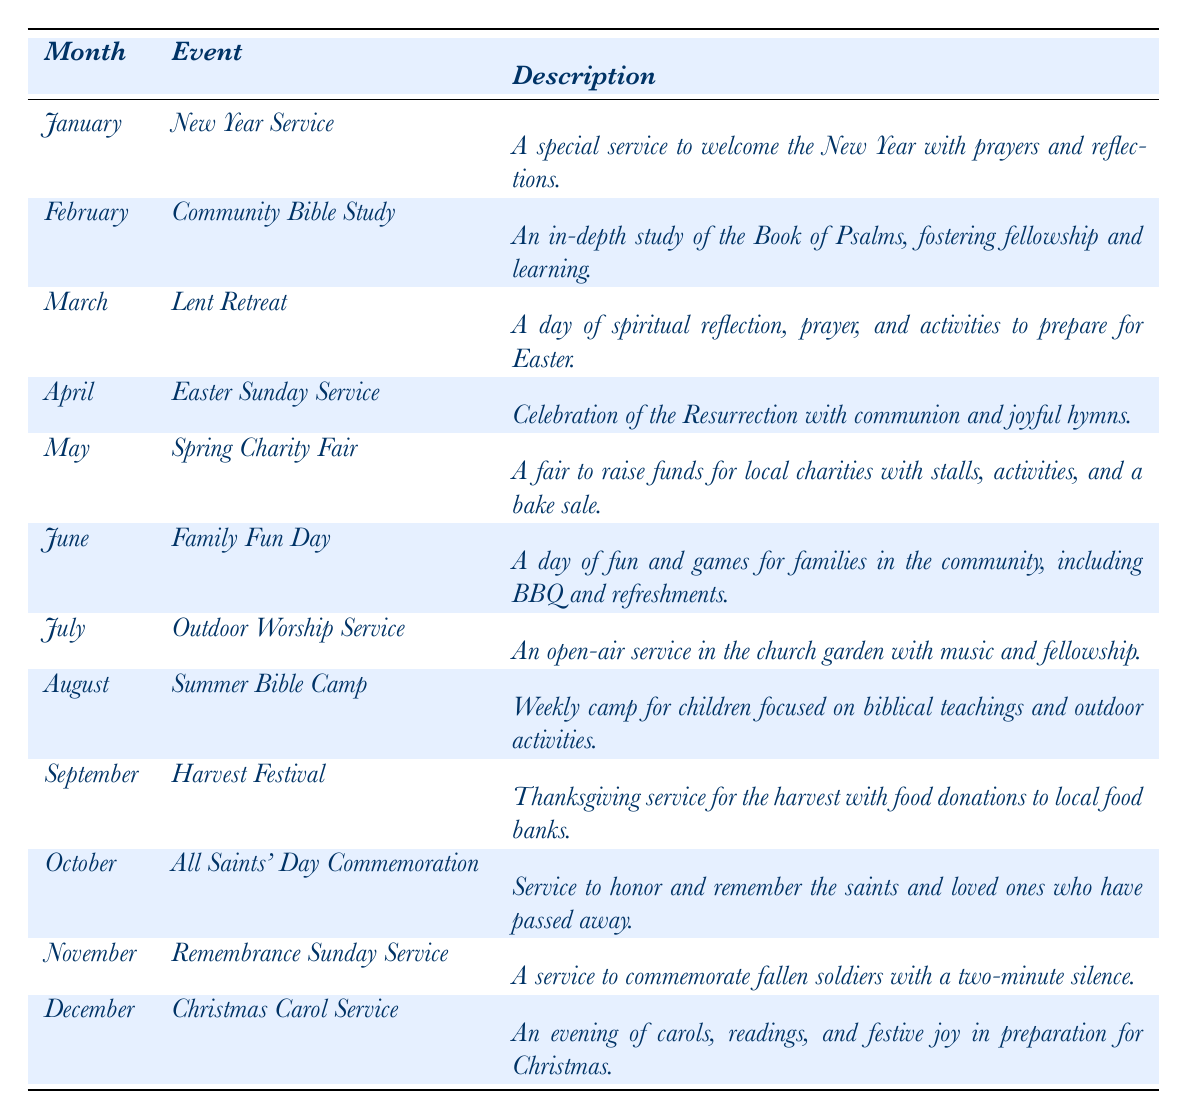What event is scheduled for April? The table lists the event for April as "Easter Sunday Service," which is found in the April row.
Answer: Easter Sunday Service How many events occur in the summer months? The summer months are June, July, and August. According to the table, there are three events: "Family Fun Day" in June, "Outdoor Worship Service" in July, and "Summer Bible Camp" in August.
Answer: 3 Is there a community Bible study event scheduled in February? Looking at the table, February does have an event titled "Community Bible Study." Therefore, the answer is yes.
Answer: Yes What month has the Spring Charity Fair, and how many events take place before it? The Spring Charity Fair occurs in May. Before May, the months listed are January, February, March, and April, resulting in four events before May.
Answer: May, 4 What is the harvest festival's date? The harvest festival is listed on the row for September, and the date mentioned is "2023-09-24."
Answer: 2023-09-24 Which event takes place on a date that has the highest number in the month? The events in October are "All Saints' Day Commemoration," which is on the 31st. This is the highest day in any month represented in the table.
Answer: All Saints' Day Commemoration How many events are there in total from January to March? From January to March, there are three events: "New Year Service" in January, "Community Bible Study" in February, and "Lent Retreat" in March. Thus, total events = 3.
Answer: 3 What is the event that follows the Easter Sunday Service? The event following "Easter Sunday Service," which is scheduled for April 9, is "Spring Charity Fair," occurring in May, based on how events are ordered chronologically in the table.
Answer: Spring Charity Fair What is the main purpose of the Christmas Carol Service as described? The description for the Christmas Carol Service indicates that it is an evening dedicated to carols, readings, and festive joy in preparation for Christmas.
Answer: Preparation for Christmas Is there an event dedicated to honoring fallen soldiers? Yes, the table indicates there is a "Remembrance Sunday Service" on November 12 which is dedicated to commemorating fallen soldiers.
Answer: Yes How many events involve community service or charity in this table? The events that involve community service or charity include the "Spring Charity Fair" and the "Harvest Festival." So there are two such events listed.
Answer: 2 